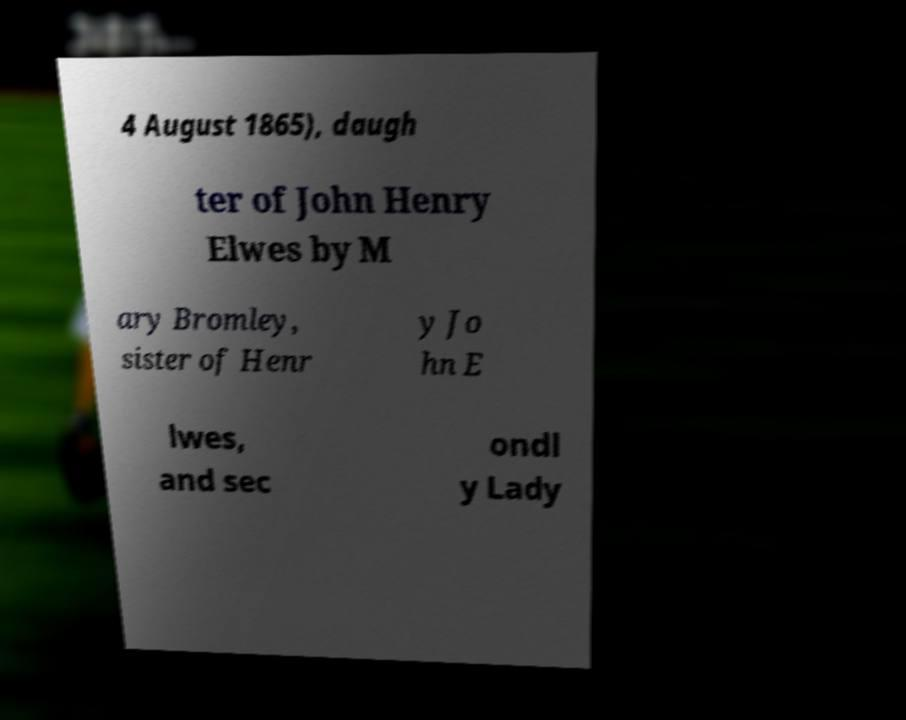There's text embedded in this image that I need extracted. Can you transcribe it verbatim? 4 August 1865), daugh ter of John Henry Elwes by M ary Bromley, sister of Henr y Jo hn E lwes, and sec ondl y Lady 